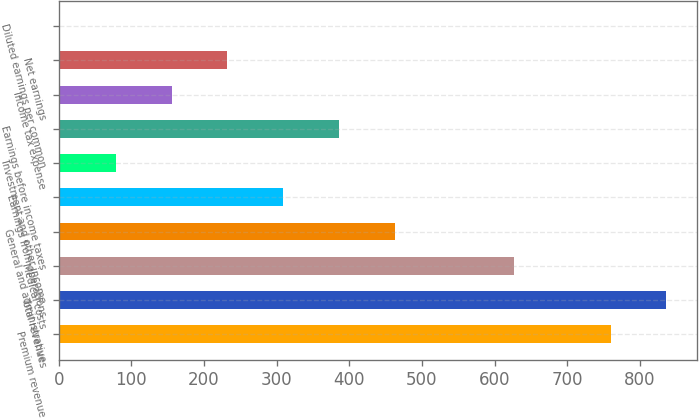Convert chart to OTSL. <chart><loc_0><loc_0><loc_500><loc_500><bar_chart><fcel>Premium revenue<fcel>Total revenues<fcel>Medical costs<fcel>General and administrative<fcel>Earnings from operations<fcel>Investment and other income<fcel>Earnings before income taxes<fcel>Income tax expense<fcel>Net earnings<fcel>Diluted earnings per common<nl><fcel>759.7<fcel>836.5<fcel>626.2<fcel>462.53<fcel>308.93<fcel>78.53<fcel>385.73<fcel>155.33<fcel>232.13<fcel>1.73<nl></chart> 